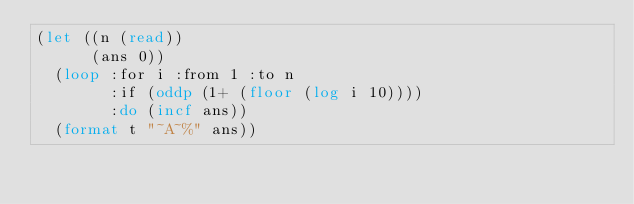Convert code to text. <code><loc_0><loc_0><loc_500><loc_500><_Lisp_>(let ((n (read))
      (ans 0))
  (loop :for i :from 1 :to n
        :if (oddp (1+ (floor (log i 10))))
        :do (incf ans))
  (format t "~A~%" ans))
</code> 